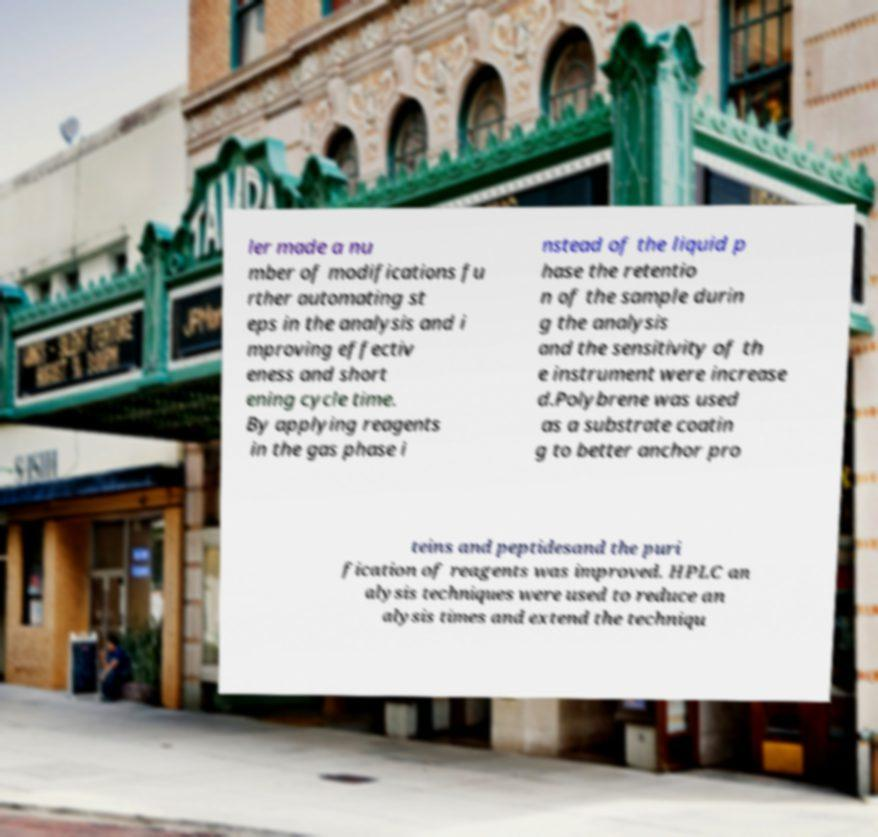Could you assist in decoding the text presented in this image and type it out clearly? ler made a nu mber of modifications fu rther automating st eps in the analysis and i mproving effectiv eness and short ening cycle time. By applying reagents in the gas phase i nstead of the liquid p hase the retentio n of the sample durin g the analysis and the sensitivity of th e instrument were increase d.Polybrene was used as a substrate coatin g to better anchor pro teins and peptidesand the puri fication of reagents was improved. HPLC an alysis techniques were used to reduce an alysis times and extend the techniqu 